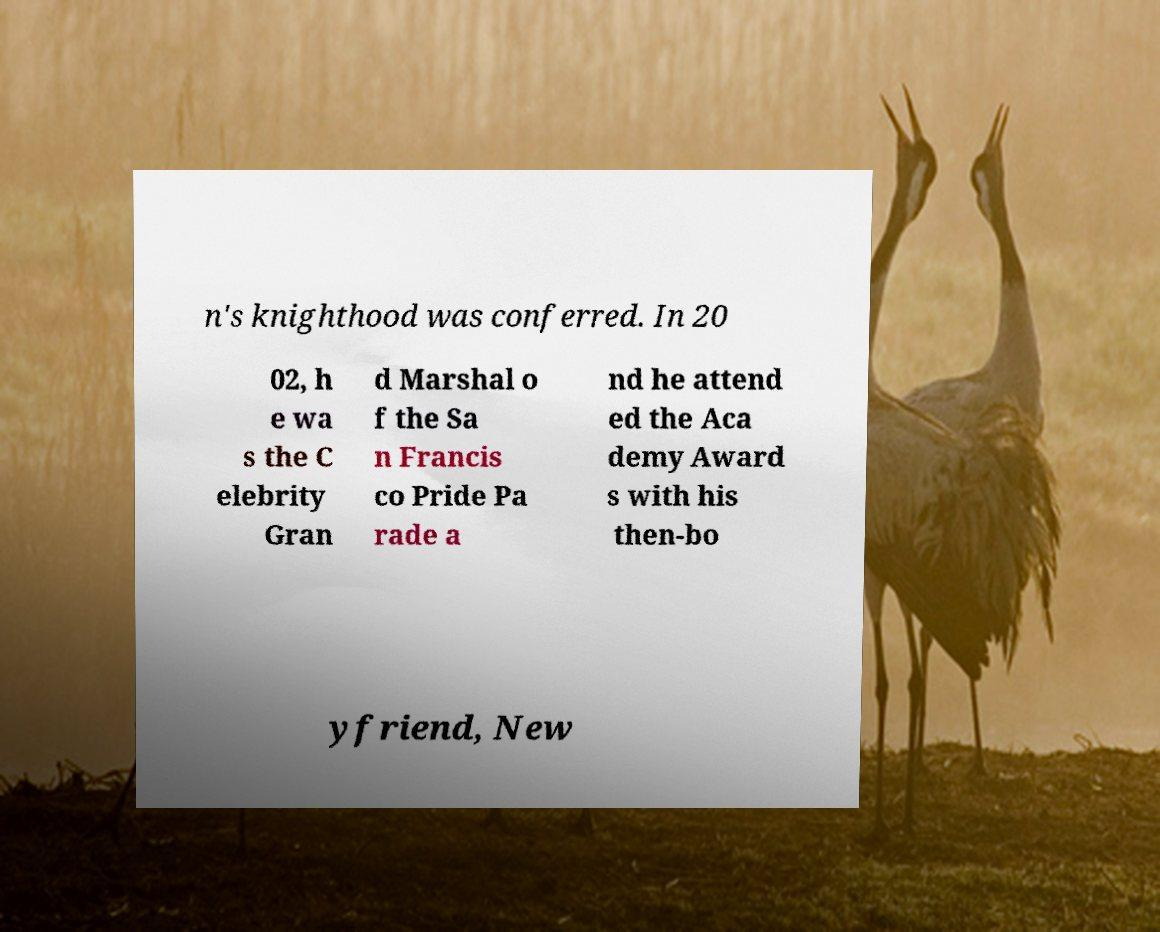Can you accurately transcribe the text from the provided image for me? n's knighthood was conferred. In 20 02, h e wa s the C elebrity Gran d Marshal o f the Sa n Francis co Pride Pa rade a nd he attend ed the Aca demy Award s with his then-bo yfriend, New 